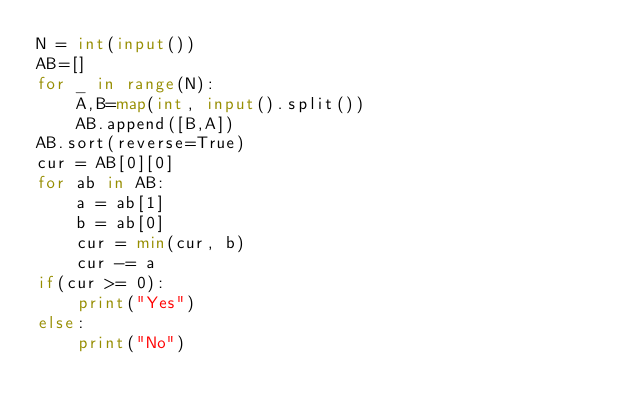Convert code to text. <code><loc_0><loc_0><loc_500><loc_500><_Python_>N = int(input())
AB=[]
for _ in range(N):
	A,B=map(int, input().split())
	AB.append([B,A])
AB.sort(reverse=True)
cur = AB[0][0]
for ab in AB:
	a = ab[1]
	b = ab[0]
	cur = min(cur, b)
	cur -= a
if(cur >= 0):
	print("Yes")
else:
	print("No")</code> 